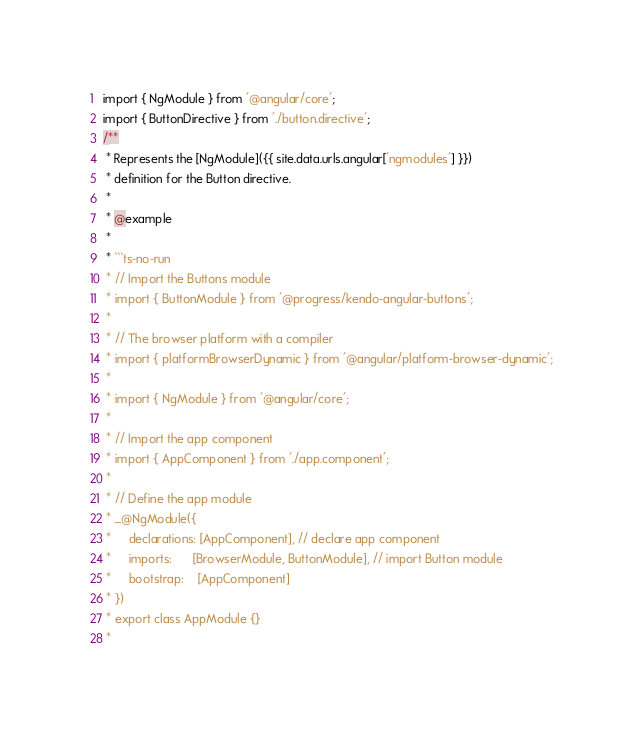<code> <loc_0><loc_0><loc_500><loc_500><_JavaScript_>import { NgModule } from '@angular/core';
import { ButtonDirective } from './button.directive';
/**
 * Represents the [NgModule]({{ site.data.urls.angular['ngmodules'] }})
 * definition for the Button directive.
 *
 * @example
 *
 * ```ts-no-run
 * // Import the Buttons module
 * import { ButtonModule } from '@progress/kendo-angular-buttons';
 *
 * // The browser platform with a compiler
 * import { platformBrowserDynamic } from '@angular/platform-browser-dynamic';
 *
 * import { NgModule } from '@angular/core';
 *
 * // Import the app component
 * import { AppComponent } from './app.component';
 *
 * // Define the app module
 * _@NgModule({
 *     declarations: [AppComponent], // declare app component
 *     imports:      [BrowserModule, ButtonModule], // import Button module
 *     bootstrap:    [AppComponent]
 * })
 * export class AppModule {}
 *</code> 